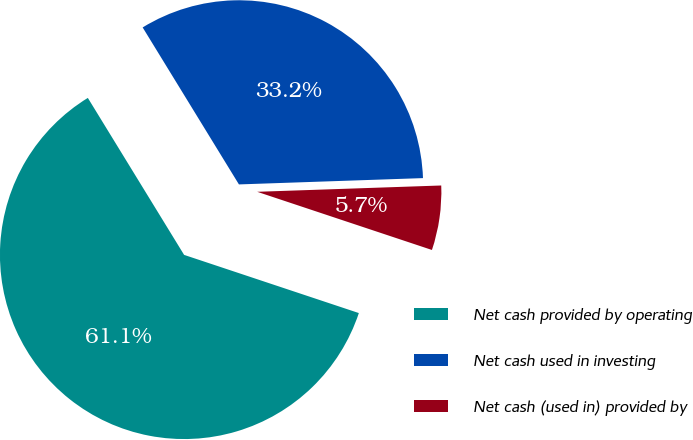Convert chart to OTSL. <chart><loc_0><loc_0><loc_500><loc_500><pie_chart><fcel>Net cash provided by operating<fcel>Net cash used in investing<fcel>Net cash (used in) provided by<nl><fcel>61.13%<fcel>33.21%<fcel>5.66%<nl></chart> 